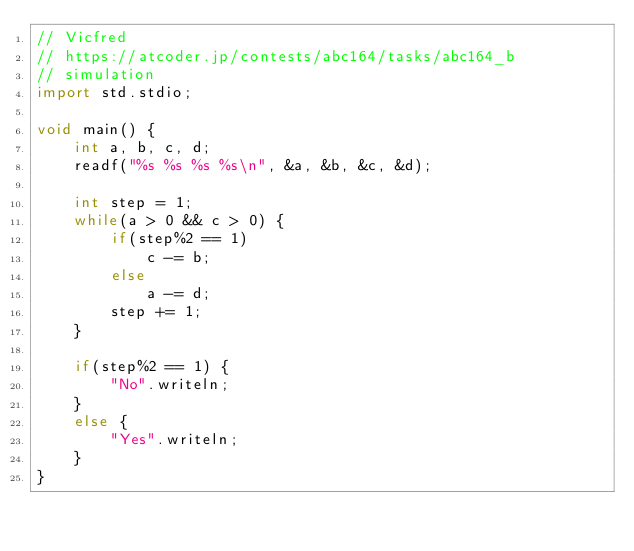<code> <loc_0><loc_0><loc_500><loc_500><_D_>// Vicfred
// https://atcoder.jp/contests/abc164/tasks/abc164_b
// simulation
import std.stdio;

void main() {
    int a, b, c, d;
    readf("%s %s %s %s\n", &a, &b, &c, &d);

    int step = 1;
    while(a > 0 && c > 0) {
        if(step%2 == 1)
            c -= b;
        else
            a -= d;
        step += 1;
    }

    if(step%2 == 1) {
        "No".writeln;
    }
    else {
        "Yes".writeln;
    }
}

</code> 